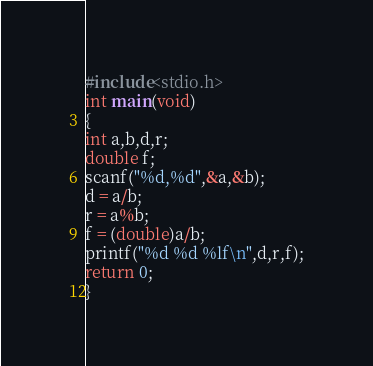Convert code to text. <code><loc_0><loc_0><loc_500><loc_500><_C_>#include<stdio.h>
int main(void)
{
int a,b,d,r;
double f;
scanf("%d,%d",&a,&b);
d = a/b;
r = a%b;
f = (double)a/b;
printf("%d %d %lf\n",d,r,f);
return 0;
}</code> 